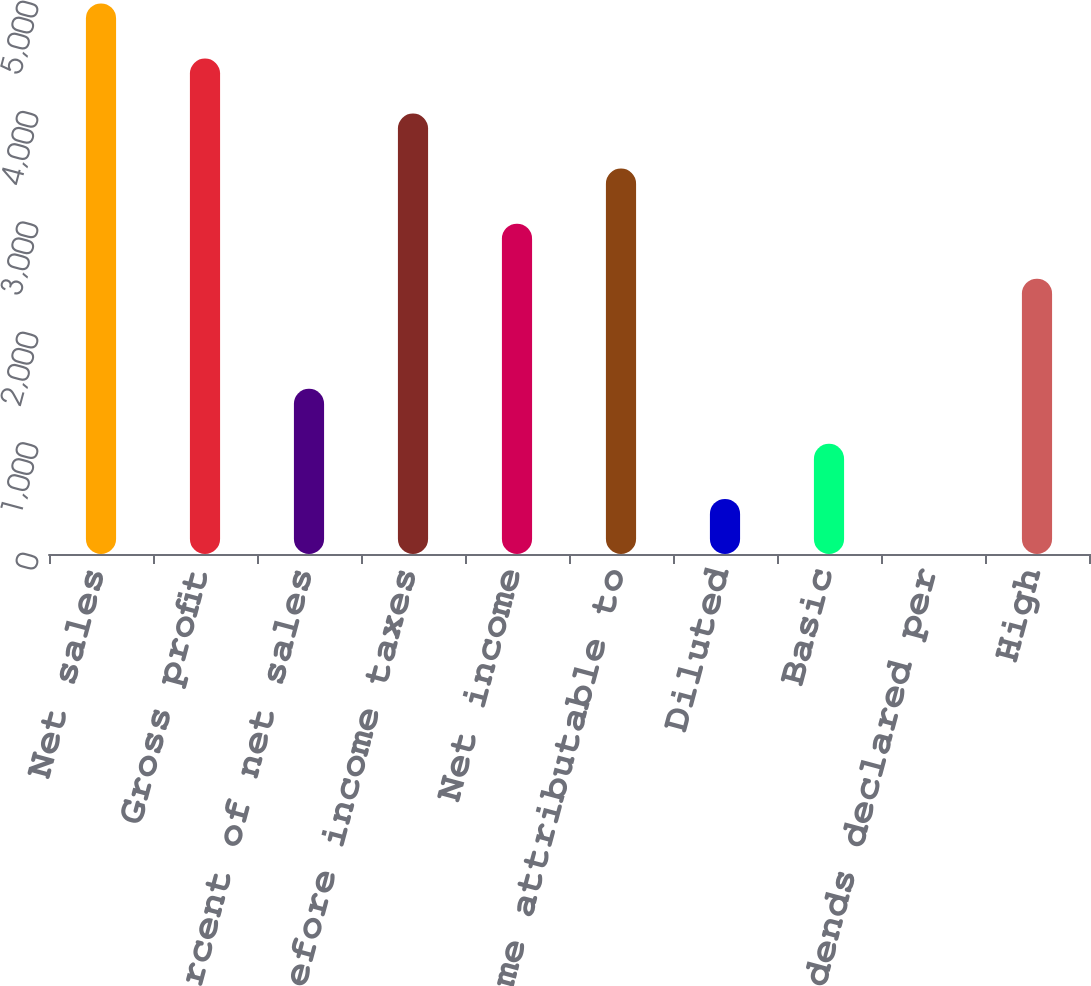<chart> <loc_0><loc_0><loc_500><loc_500><bar_chart><fcel>Net sales<fcel>Gross profit<fcel>Percent of net sales<fcel>Income before income taxes<fcel>Net income<fcel>Net income attributable to<fcel>Diluted<fcel>Basic<fcel>Cash dividends declared per<fcel>High<nl><fcel>4987<fcel>4488.33<fcel>1496.49<fcel>3989.69<fcel>2992.41<fcel>3491.05<fcel>499.21<fcel>997.85<fcel>0.57<fcel>2493.77<nl></chart> 